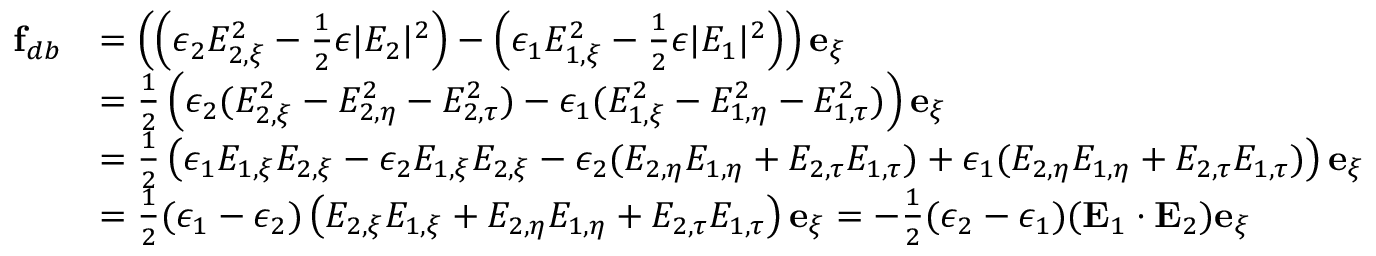Convert formula to latex. <formula><loc_0><loc_0><loc_500><loc_500>\begin{array} { r l } { f _ { d b } } & { = \left ( \left ( \epsilon _ { 2 } E _ { 2 , \xi } ^ { 2 } - \frac { 1 } { 2 } \epsilon | E _ { 2 } | ^ { 2 } \right ) - \left ( \epsilon _ { 1 } E _ { 1 , \xi } ^ { 2 } - \frac { 1 } { 2 } \epsilon | E _ { 1 } | ^ { 2 } \right ) \right ) e _ { \xi } } \\ & { = \frac { 1 } { 2 } \left ( \epsilon _ { 2 } ( E _ { 2 , \xi } ^ { 2 } - E _ { 2 , \eta } ^ { 2 } - E _ { 2 , \tau } ^ { 2 } ) - \epsilon _ { 1 } ( E _ { 1 , \xi } ^ { 2 } - E _ { 1 , \eta } ^ { 2 } - E _ { 1 , \tau } ^ { 2 } ) \right ) e _ { \xi } } \\ & { = \frac { 1 } { 2 } \left ( \epsilon _ { 1 } E _ { 1 , \xi } E _ { 2 , \xi } - \epsilon _ { 2 } E _ { 1 , \xi } E _ { 2 , \xi } - \epsilon _ { 2 } ( E _ { 2 , \eta } E _ { 1 , \eta } + E _ { 2 , \tau } E _ { 1 , \tau } ) + \epsilon _ { 1 } ( E _ { 2 , \eta } E _ { 1 , \eta } + E _ { 2 , \tau } E _ { 1 , \tau } ) \right ) e _ { \xi } } \\ & { = \frac { 1 } { 2 } ( \epsilon _ { 1 } - \epsilon _ { 2 } ) \left ( E _ { 2 , \xi } E _ { 1 , \xi } + E _ { 2 , \eta } E _ { 1 , \eta } + E _ { 2 , \tau } E _ { 1 , \tau } \right ) e _ { \xi } = - \frac { 1 } { 2 } ( \epsilon _ { 2 } - \epsilon _ { 1 } ) ( E _ { 1 } \cdot E _ { 2 } ) e _ { \xi } } \end{array}</formula> 